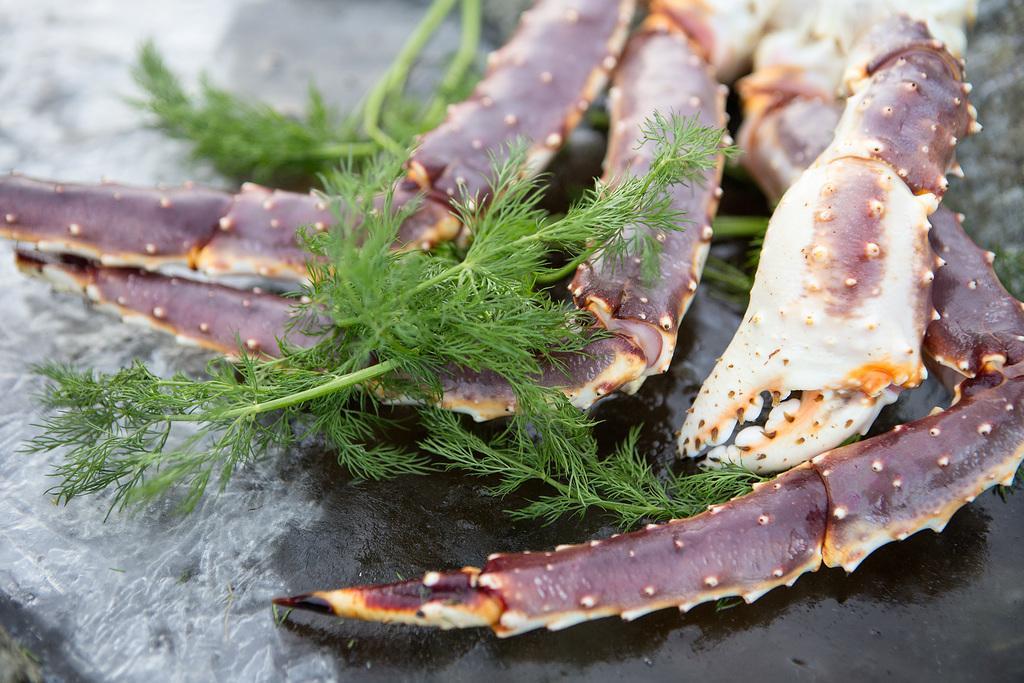Please provide a concise description of this image. In this image I can see a crab and soya leaves on a table. This image is taken during a day. 